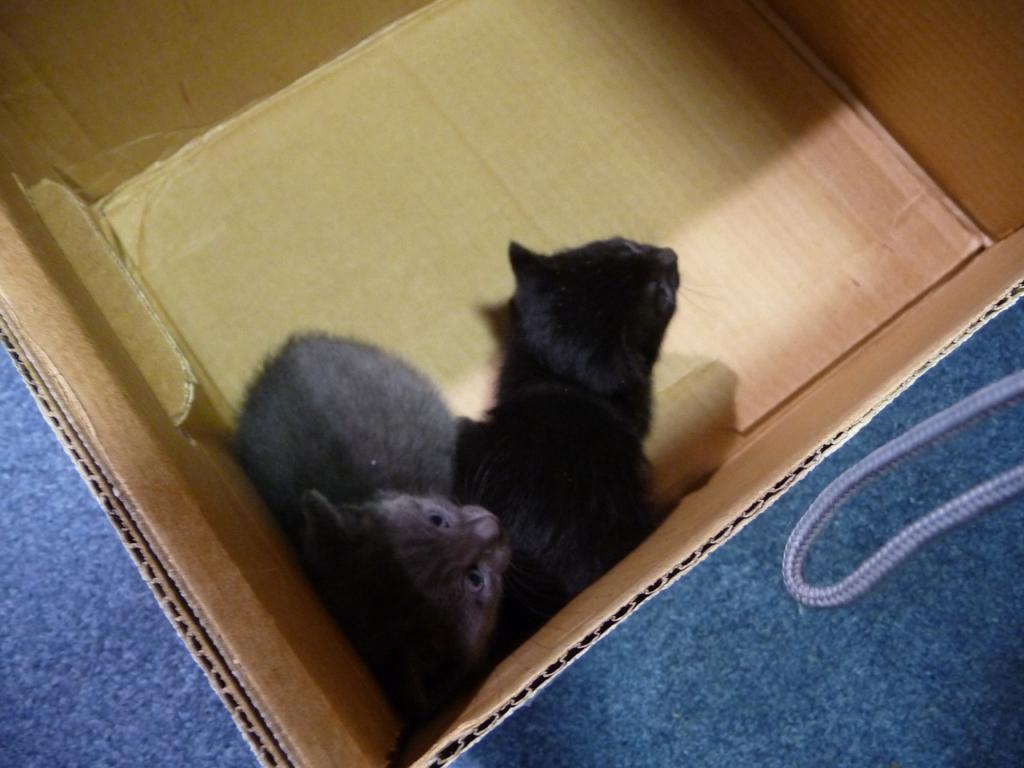What object is present in the image? There is a box in the image. What is inside the box? There are two cats in the box. What type of amusement can be seen in the image? There is no amusement present in the image; it features a box with two cats inside. How many tickets are visible in the image? There are no tickets present in the image. 